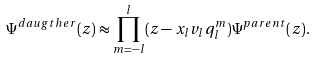<formula> <loc_0><loc_0><loc_500><loc_500>\Psi ^ { d a u g t h e r } ( z ) \approx \prod _ { m = - l } ^ { l } ( z - x _ { l } v _ { l } q _ { l } ^ { m } ) \Psi ^ { p a r e n t } ( z ) .</formula> 